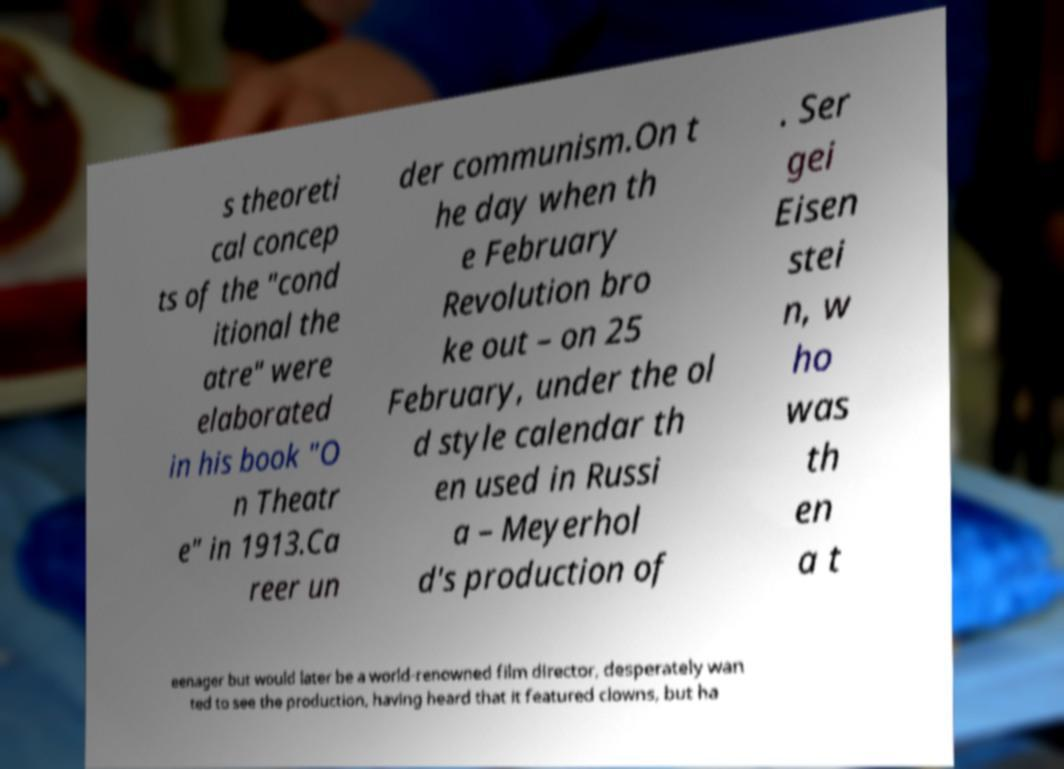I need the written content from this picture converted into text. Can you do that? s theoreti cal concep ts of the "cond itional the atre" were elaborated in his book "O n Theatr e" in 1913.Ca reer un der communism.On t he day when th e February Revolution bro ke out – on 25 February, under the ol d style calendar th en used in Russi a – Meyerhol d's production of . Ser gei Eisen stei n, w ho was th en a t eenager but would later be a world-renowned film director, desperately wan ted to see the production, having heard that it featured clowns, but ha 